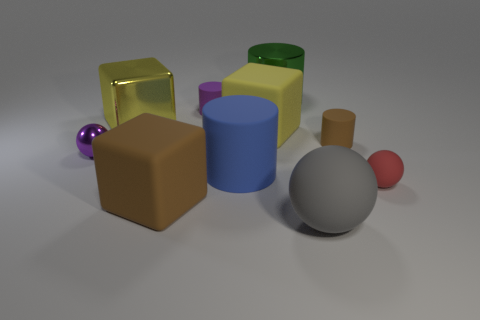There is a matte cube that is the same color as the metal cube; what size is it?
Your answer should be compact. Large. Is the number of small cylinders that are behind the yellow rubber block greater than the number of purple rubber cylinders that are to the right of the tiny matte ball?
Keep it short and to the point. Yes. Does the small matte object on the left side of the big blue cylinder have the same color as the small shiny sphere?
Make the answer very short. Yes. What size is the purple metal object?
Your response must be concise. Small. What material is the blue thing that is the same size as the gray object?
Make the answer very short. Rubber. What color is the small metal ball that is in front of the yellow metallic object?
Ensure brevity in your answer.  Purple. How many yellow blocks are there?
Provide a succinct answer. 2. Are there any tiny matte cylinders that are to the left of the brown object that is right of the big sphere to the right of the big blue rubber cylinder?
Keep it short and to the point. Yes. The yellow matte object that is the same size as the metallic cube is what shape?
Provide a succinct answer. Cube. How many other objects are there of the same color as the metal cube?
Give a very brief answer. 1. 